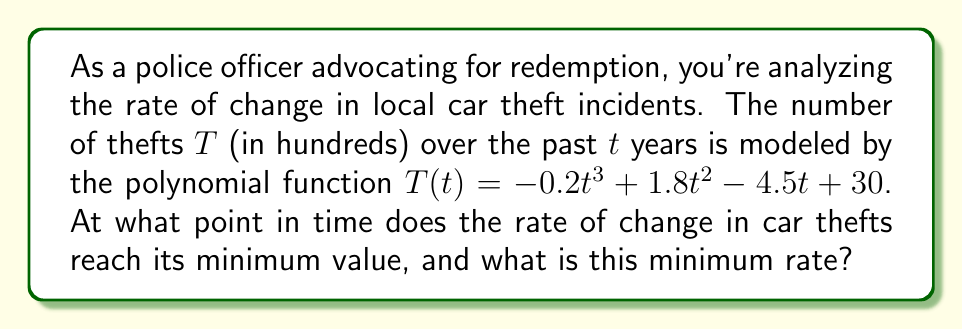Can you solve this math problem? To solve this problem, we need to follow these steps:

1) The rate of change is given by the first derivative of $T(t)$. Let's call this $T'(t)$:

   $T'(t) = -0.6t^2 + 3.6t - 4.5$

2) To find the minimum rate of change, we need to find where the second derivative $T''(t)$ equals zero:

   $T''(t) = -1.2t + 3.6$

3) Set $T''(t) = 0$ and solve for $t$:

   $-1.2t + 3.6 = 0$
   $-1.2t = -3.6$
   $t = 3$

4) This critical point $t = 3$ gives us the time when the rate of change reaches its extremum. To confirm it's a minimum, we can check that $T'''(t) = -1.2 < 0$.

5) To find the minimum rate, we substitute $t = 3$ into $T'(t)$:

   $T'(3) = -0.6(3)^2 + 3.6(3) - 4.5$
          $= -5.4 + 10.8 - 4.5$
          $= 0.9$

Therefore, the rate of change reaches its minimum value after 3 years, and this minimum rate is 0.9 hundred (or 90) car thefts per year.
Answer: After 3 years; -90 car thefts/year 